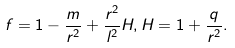<formula> <loc_0><loc_0><loc_500><loc_500>f = 1 - \frac { m } { r ^ { 2 } } + \frac { r ^ { 2 } } { l ^ { 2 } } H , H = 1 + \frac { q } { r ^ { 2 } } .</formula> 